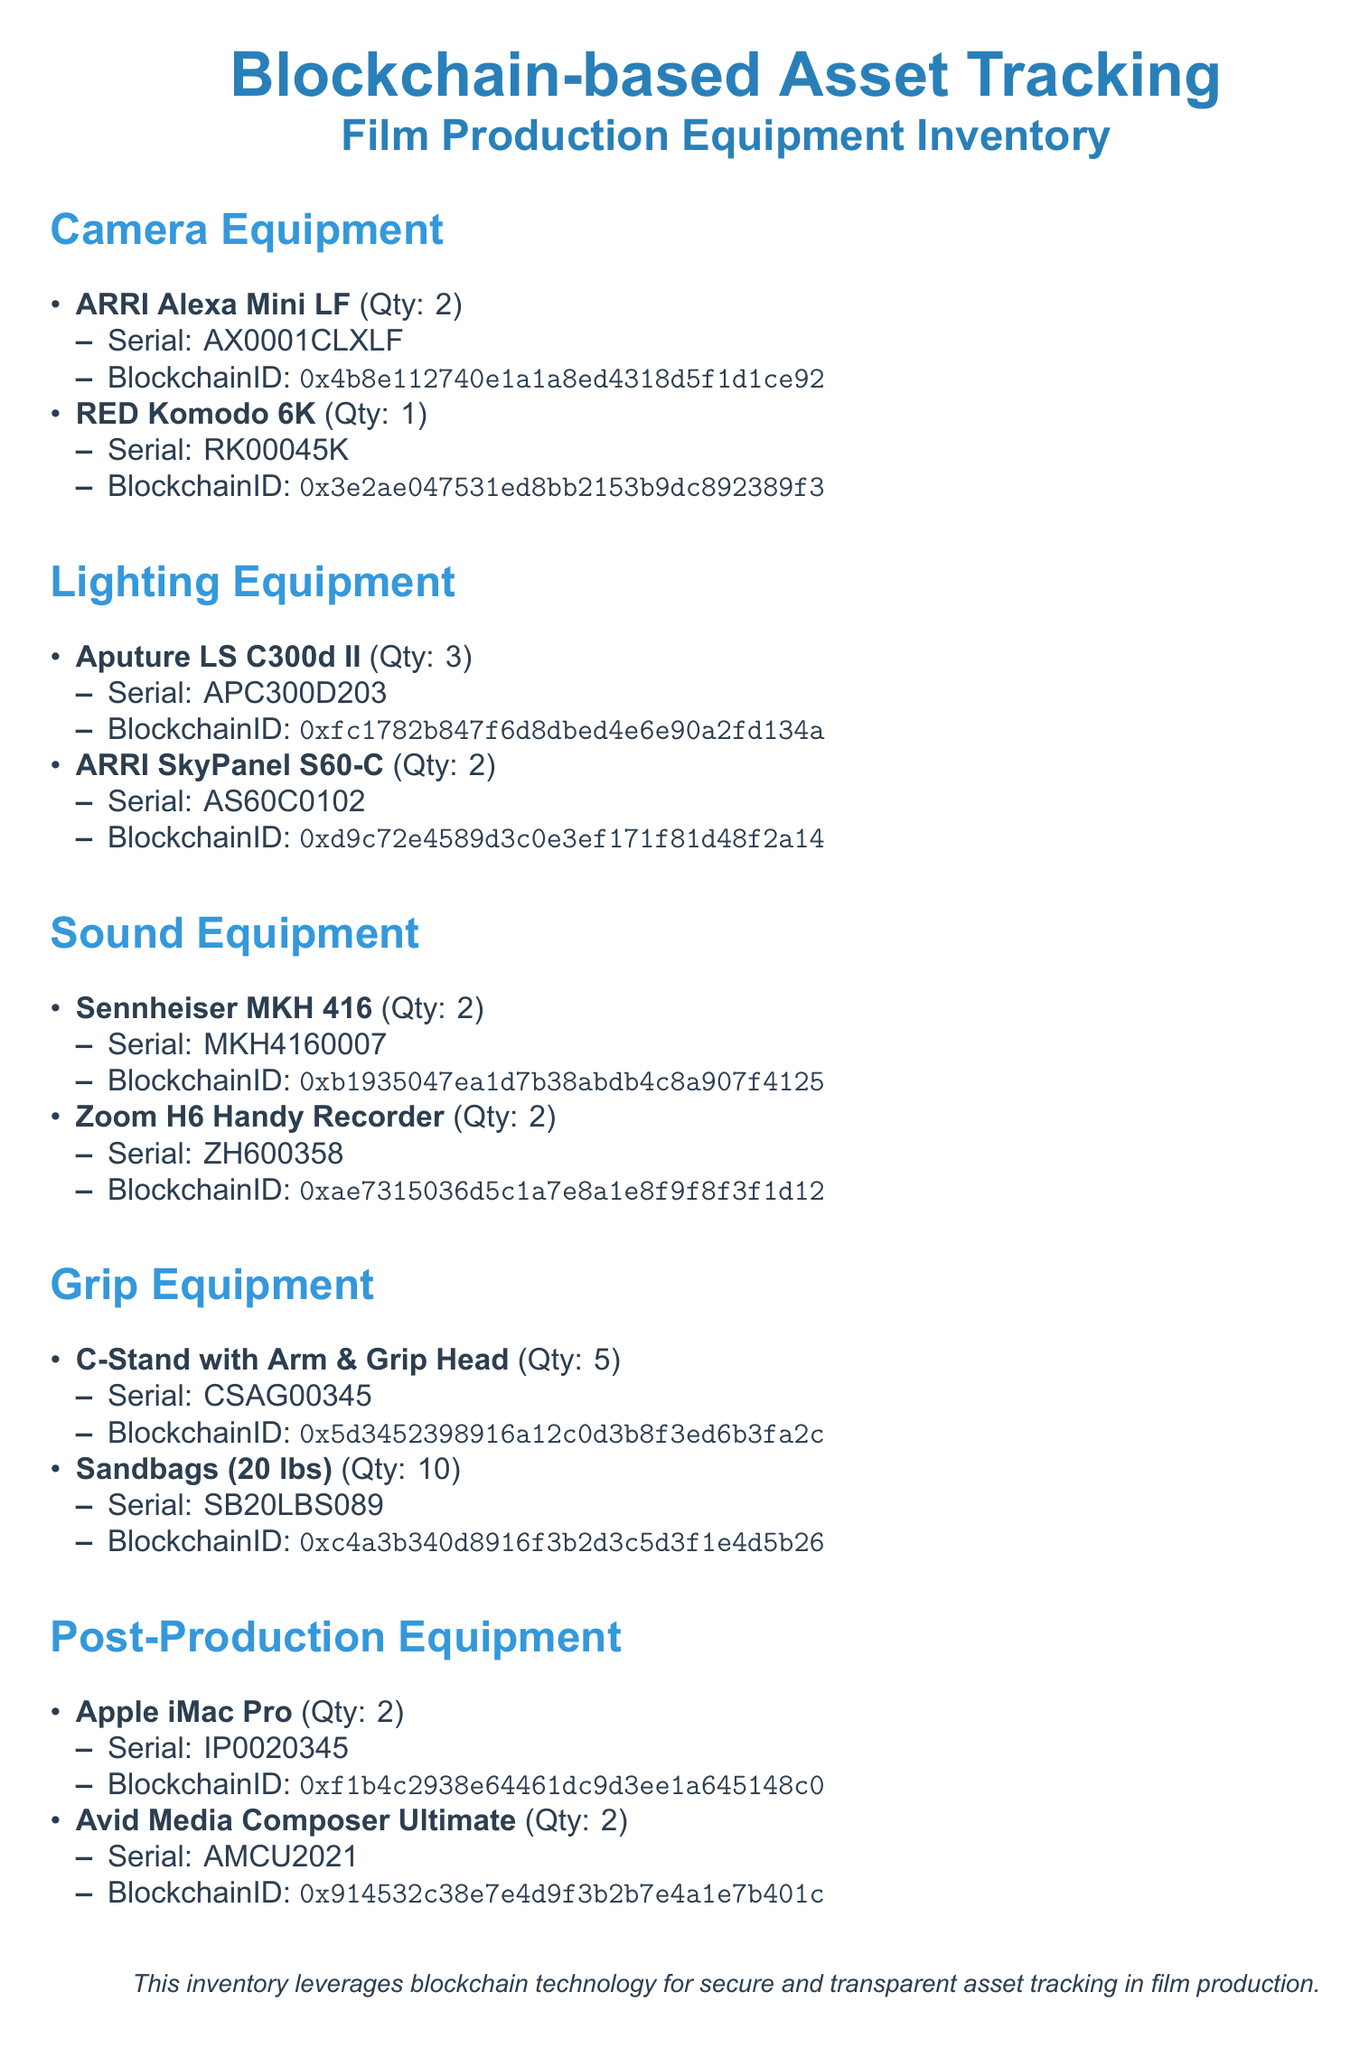What is the quantity of ARRI Alexa Mini LF? The document lists the quantity of ARRI Alexa Mini LF under Camera Equipment, which is stated to be 2.
Answer: 2 What is the Serial number of the RED Komodo 6K? The Serial number for the RED Komodo 6K can be found in the document under Camera Equipment, listed as RK00045K.
Answer: RK00045K How many Aputure LS C300d II are available? The number of Aputure LS C300d II listed under Lighting Equipment is given as 3 in the document.
Answer: 3 What is the Blockchain ID for the Sennheiser MKH 416? The document specifies the Blockchain ID for Sennheiser MKH 416 listed under Sound Equipment, which is 0xb1935047ea1d7b38abdb4c8a907f4125.
Answer: 0xb1935047ea1d7b38abdb4c8a907f4125 Which equipment has the highest quantity in the Grip Equipment section? The document shows the highest quantity in the Grip Equipment section is for Sandbags, with a total of 10 listed.
Answer: 10 Which type of equipment is the Apple iMac Pro classified as? The document classifies the Apple iMac Pro under the Post-Production Equipment category, as stated in the heading.
Answer: Post-Production Equipment What color is the section header for Camera Equipment? The document uses a section color of RGB(52,152,219) for the Camera Equipment header, which corresponds to a specific shade of blue.
Answer: Blue What is the total number of camera equipment listed? The total camera equipment items can be found by counting listed items, which includes 2 types: ARRI Alexa Mini LF and RED Komodo 6K, totaling 3 items.
Answer: 3 What type of document is this? The document serves as a Packing list specifically for Film Production Equipment Inventory.
Answer: Packing list 